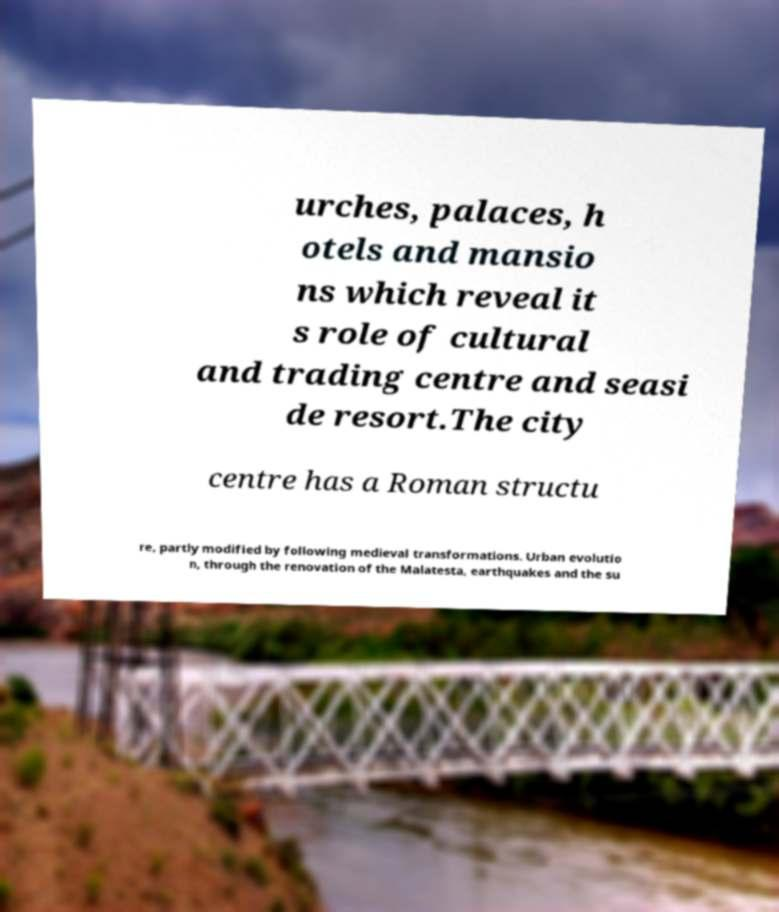Can you read and provide the text displayed in the image?This photo seems to have some interesting text. Can you extract and type it out for me? urches, palaces, h otels and mansio ns which reveal it s role of cultural and trading centre and seasi de resort.The city centre has a Roman structu re, partly modified by following medieval transformations. Urban evolutio n, through the renovation of the Malatesta, earthquakes and the su 